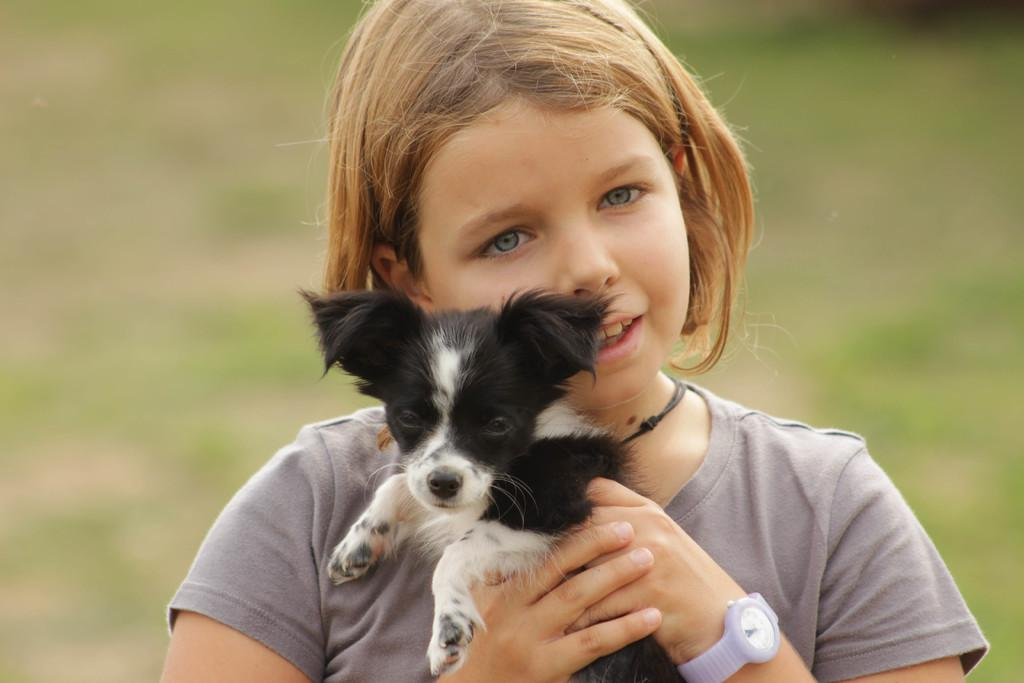Who is the main subject in the image? There is a girl in the image. What is the girl holding in the image? The girl is holding a dog. What accessory is the girl wearing in the image? The girl is wearing a wrist watch. How many trees can be seen in the image? There are no trees visible in the image; it features a girl holding a dog and wearing a wrist watch. What type of currency is present in the image? There is no currency present in the image. 